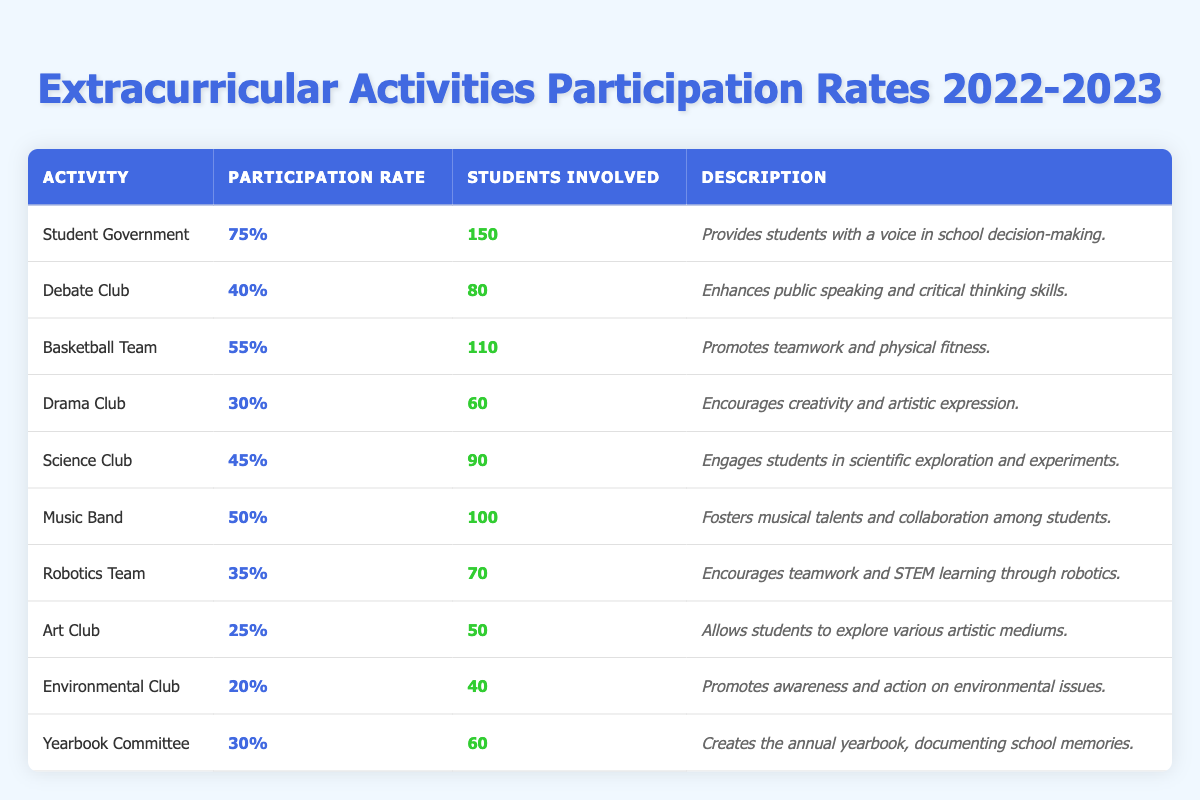What is the participation rate for the Student Government activity? The participation rate for the Student Government activity is directly mentioned in the table; it is listed as 75%.
Answer: 75% How many students are involved in the Music Band? The number of students involved in the Music Band is provided in the table under the "Students Involved" column, which states 100 students.
Answer: 100 Which extracurricular activity has the highest participation rate? By scanning through the participation rates in the table, the Student Government has the highest participation rate at 75%.
Answer: Student Government What is the average participation rate of all activities listed? To find the average participation rate, sum all rates (75 + 40 + 55 + 30 + 45 + 50 + 35 + 25 + 20 + 30) =  400, and divide by the number of activities (10). Thus, the average is 400/10 = 40%.
Answer: 40% Does the Art Club have a higher participation rate than the Environmental Club? In the table, the Art Club has a participation rate of 25%, and the Environmental Club has a participation rate of 20%. Since 25% is greater than 20%, the statement is true.
Answer: Yes What percentage of students are involved in the Robotics Team compared to the total of all students involved in extracurricular activities? First, add up the total students involved (150 + 80 + 110 + 60 + 90 + 100 + 70 + 50 + 40 + 60 = 1010). Then, calculate the percentage of Robotics Team students (70) out of the total (1010): (70/1010) * 100 ≈ 6.93%.
Answer: Approximately 6.93% How many more students are involved in the Basketball Team than in the Drama Club? The table indicates that the Basketball Team involves 110 students while the Drama Club has 60 students. The difference is calculated as 110 - 60 = 50.
Answer: 50 Which activity has both a participation rate and students involved below the average of their respective columns? The average participation rate is 40%, and the average students involved is 101. All activities below these averages are Environmental Club (20% and 40 students) and Art Club (25% and 50 students).
Answer: Environmental Club and Art Club Does the Debate Club participation rate exceed 30%? The table shows that the Debate Club has a participation rate of 40%, which is greater than 30%, making the statement true.
Answer: Yes If all participation rates are increased by 10%, what would be the new participation rate for the Science Club? The current participation rate for the Science Club is 45%. Increasing it by 10% gives a new rate of 45 + 10 = 55%.
Answer: 55% 